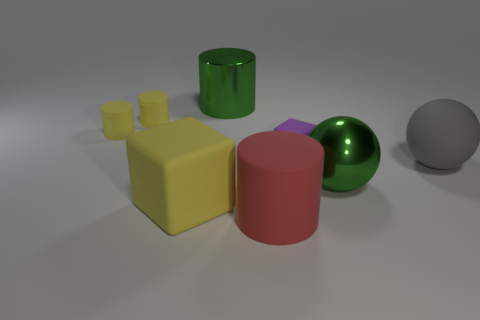What is the size of the yellow cube that is the same material as the big gray ball? The yellow cube appears to be medium-sized when compared to other objects in the image, particularly the large gray sphere, which shares the same matte surface texture. While it is smaller than the green cylinder and the red cylinder, it is larger than the small yellow cubes beside it. 